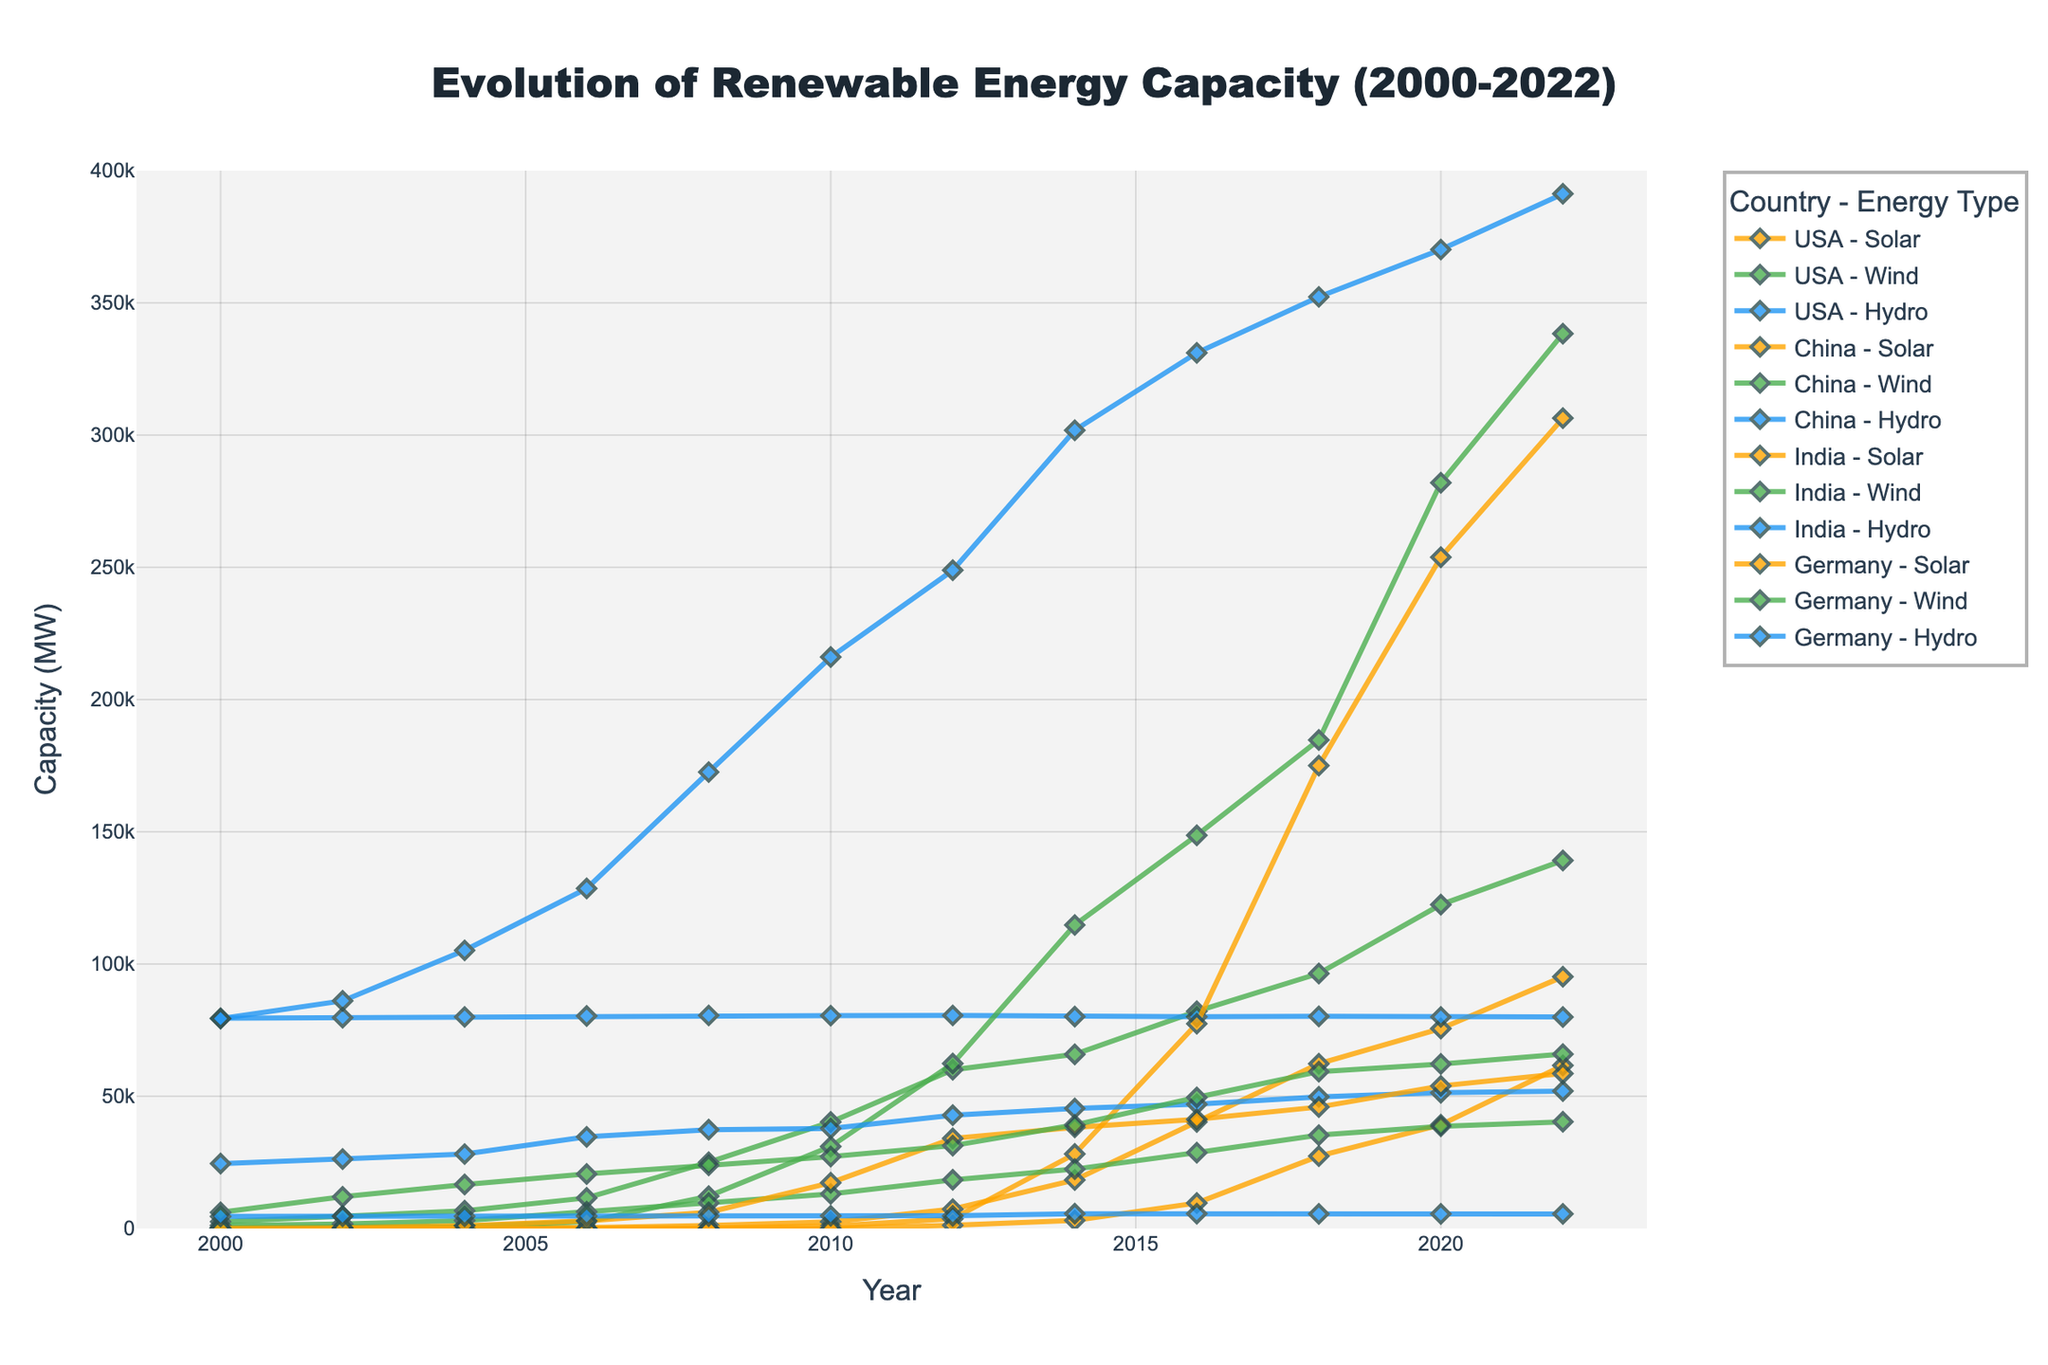What year did USA have the highest solar capacity? By looking at the trend line for USA Solar, it shows an increase over the years, peaking in 2022.
Answer: 2022 Which country had the highest wind capacity in 2022? By comparing the end points of the wind capacity lines for each country, China reaches the highest point in 2022.
Answer: China What is the sum of solar capacity in Germany and India in 2020? Check the values for Germany Solar and India Solar in 2020. Germany Solar is 53913 and India Solar is 39211. Sum them up: 53913 + 39211 = 93124.
Answer: 93124 How did the hydro capacity in China change from 2006 to 2016? Compare the values for China Hydro in 2006 (128570) and 2016 (331110). Calculate the difference: 331110 - 128570 = 202540.
Answer: Increased by 202540 Which renewable energy type saw the most significant increase in USA from 2000 to 2022? By examining the trends for solar, wind, and hydro in the USA, solar has the most significant upward trend, starting from a low value of 4 in 2000 to 95200 in 2022.
Answer: Solar Did any country have a decreasing trend in any energy type from 2020 to 2022? Compare the values for 2020 and 2022 for each energy type in all countries. All trends are either stable or increasing, there is no decreasing trend from 2020 to 2022.
Answer: No What was the average wind capacity in Germany between 2014 and 2018? Check the values for Germany Wind in 2014 (39165), 2016 (49586), and 2018 (59311). Calculate the average: (39165 + 49586 + 59381) / 3 = 46020.67.
Answer: 46020.67 How does the solar capacity of China in 2018 compare to India's in the same year? Compare the values for China Solar and India Solar in 2018. China Solar is 175018 and India Solar is 27356. 175018 is significantly greater than 27356.
Answer: China > India Which energy type in India doubled its capacity between 2010 and 2016? Compare values from 2010 to 2016 for all energy types in India. India Solar increased from 72 to 9647, which is well beyond doubling.
Answer: Solar What visual difference shows the energy type with the highest capacity overall from 2000 to 2022? The hydro lines for all countries consistently stay at the highest range compared to solar and wind lines, indicating hydro has the highest capacity.
Answer: Hydro 